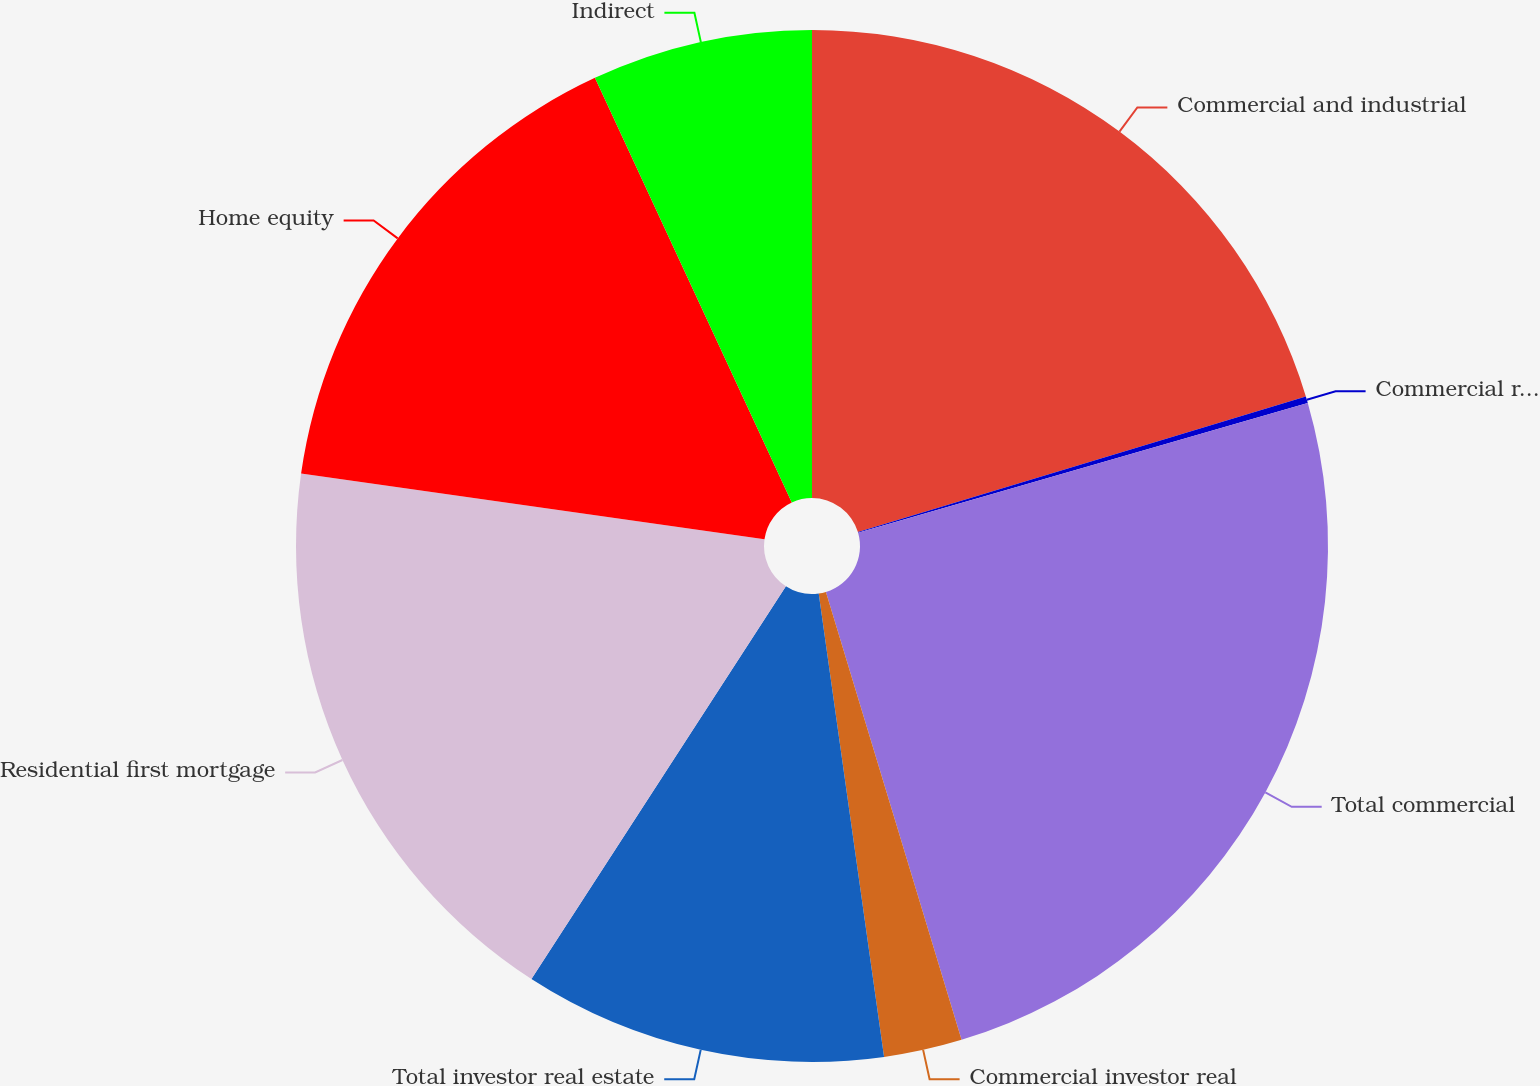<chart> <loc_0><loc_0><loc_500><loc_500><pie_chart><fcel>Commercial and industrial<fcel>Commercial real estate<fcel>Total commercial<fcel>Commercial investor real<fcel>Total investor real estate<fcel>Residential first mortgage<fcel>Home equity<fcel>Indirect<nl><fcel>20.32%<fcel>0.21%<fcel>24.79%<fcel>2.45%<fcel>11.38%<fcel>18.09%<fcel>15.85%<fcel>6.91%<nl></chart> 